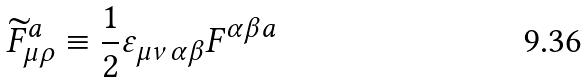Convert formula to latex. <formula><loc_0><loc_0><loc_500><loc_500>\widetilde { F } _ { \mu \rho } ^ { a } \equiv \frac { 1 } { 2 } \varepsilon _ { \mu \nu \alpha \beta } F ^ { \alpha \beta a }</formula> 